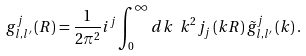Convert formula to latex. <formula><loc_0><loc_0><loc_500><loc_500>g _ { l , l ^ { \prime } } ^ { j } \left ( R \right ) = \frac { 1 } { 2 \pi ^ { 2 } } i ^ { j } \int _ { 0 } ^ { \infty } d k \ k ^ { 2 } j _ { j } \left ( k R \right ) \tilde { g } _ { l , l ^ { \prime } } ^ { j } \left ( k \right ) .</formula> 